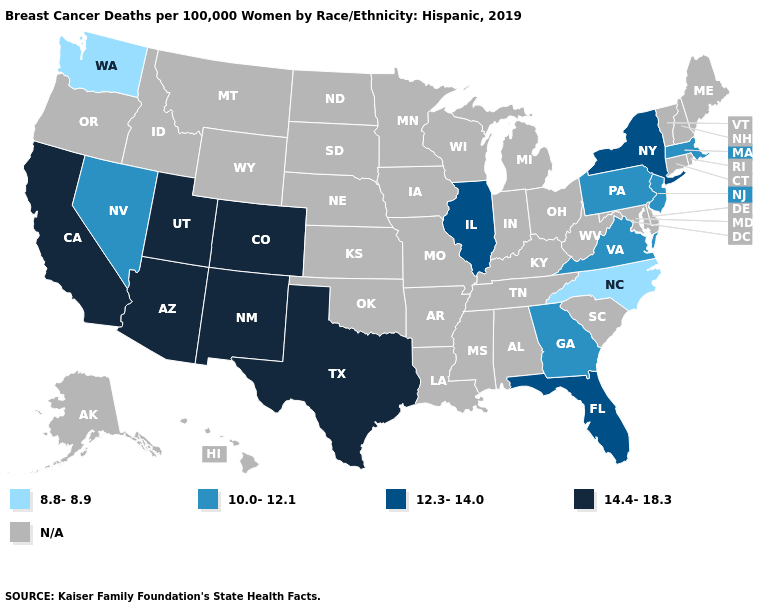Among the states that border California , which have the lowest value?
Write a very short answer. Nevada. Which states hav the highest value in the Northeast?
Keep it brief. New York. Name the states that have a value in the range 12.3-14.0?
Give a very brief answer. Florida, Illinois, New York. Does North Carolina have the lowest value in the South?
Quick response, please. Yes. What is the value of Nevada?
Write a very short answer. 10.0-12.1. Which states have the lowest value in the USA?
Keep it brief. North Carolina, Washington. Is the legend a continuous bar?
Short answer required. No. Name the states that have a value in the range 10.0-12.1?
Concise answer only. Georgia, Massachusetts, Nevada, New Jersey, Pennsylvania, Virginia. What is the value of Hawaii?
Keep it brief. N/A. What is the value of Illinois?
Write a very short answer. 12.3-14.0. Does Georgia have the highest value in the South?
Answer briefly. No. 